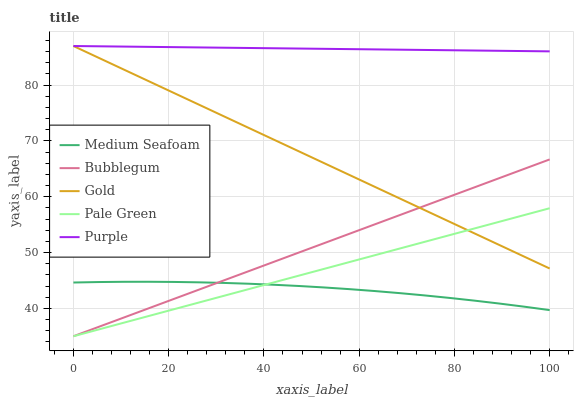Does Medium Seafoam have the minimum area under the curve?
Answer yes or no. Yes. Does Purple have the maximum area under the curve?
Answer yes or no. Yes. Does Gold have the minimum area under the curve?
Answer yes or no. No. Does Gold have the maximum area under the curve?
Answer yes or no. No. Is Purple the smoothest?
Answer yes or no. Yes. Is Medium Seafoam the roughest?
Answer yes or no. Yes. Is Gold the smoothest?
Answer yes or no. No. Is Gold the roughest?
Answer yes or no. No. Does Pale Green have the lowest value?
Answer yes or no. Yes. Does Gold have the lowest value?
Answer yes or no. No. Does Gold have the highest value?
Answer yes or no. Yes. Does Pale Green have the highest value?
Answer yes or no. No. Is Medium Seafoam less than Purple?
Answer yes or no. Yes. Is Purple greater than Bubblegum?
Answer yes or no. Yes. Does Purple intersect Gold?
Answer yes or no. Yes. Is Purple less than Gold?
Answer yes or no. No. Is Purple greater than Gold?
Answer yes or no. No. Does Medium Seafoam intersect Purple?
Answer yes or no. No. 